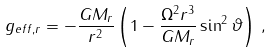<formula> <loc_0><loc_0><loc_500><loc_500>g _ { e f f , r } = - \frac { G M _ { r } } { r ^ { 2 } } \left ( 1 - \frac { \Omega ^ { 2 } r ^ { 3 } } { G M _ { r } } \sin ^ { 2 } \vartheta \right ) \, ,</formula> 